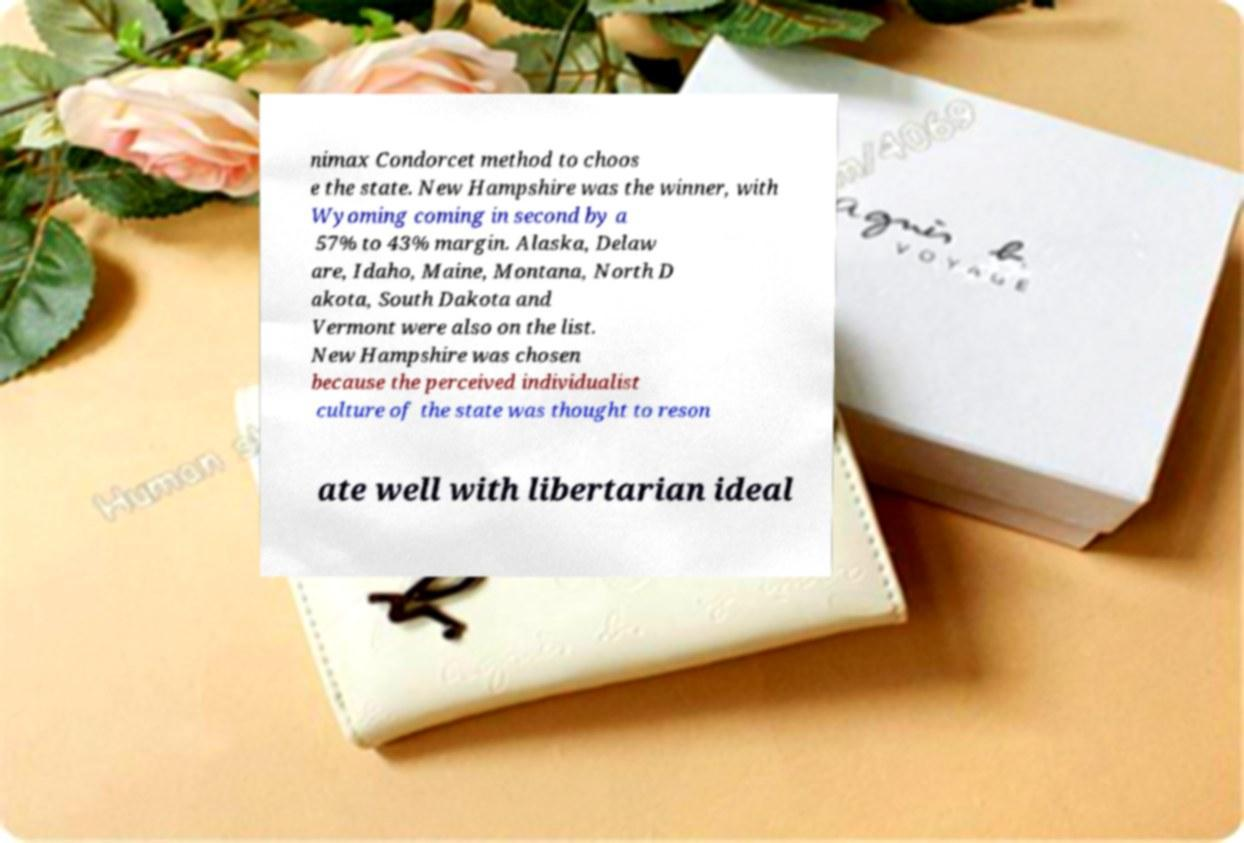There's text embedded in this image that I need extracted. Can you transcribe it verbatim? nimax Condorcet method to choos e the state. New Hampshire was the winner, with Wyoming coming in second by a 57% to 43% margin. Alaska, Delaw are, Idaho, Maine, Montana, North D akota, South Dakota and Vermont were also on the list. New Hampshire was chosen because the perceived individualist culture of the state was thought to reson ate well with libertarian ideal 